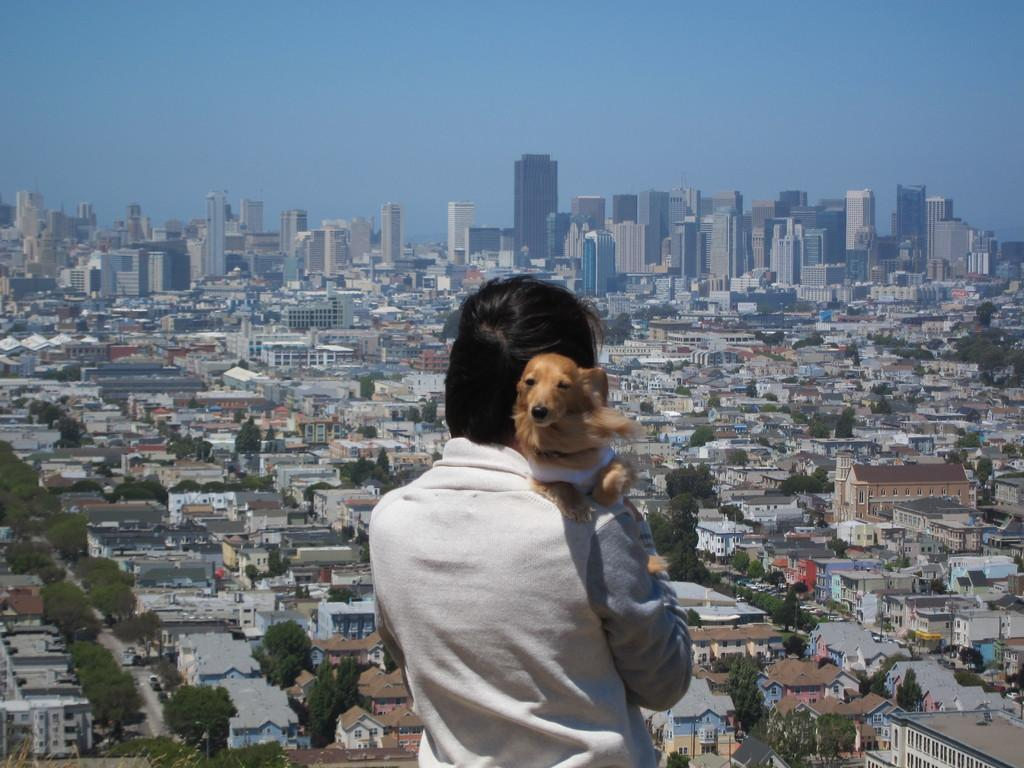What is the person in the image holding? The person is holding a dog in the image. What is the person wearing? The person is wearing white clothes. What can be seen in the background of the image? There are buildings, trees, and the sky visible in the background of the image. What is the purpose of the faucet in the image? There is no faucet present in the image. What type of beast is the person trying to tame in the image? There is no beast present in the image; the person is holding a dog. 